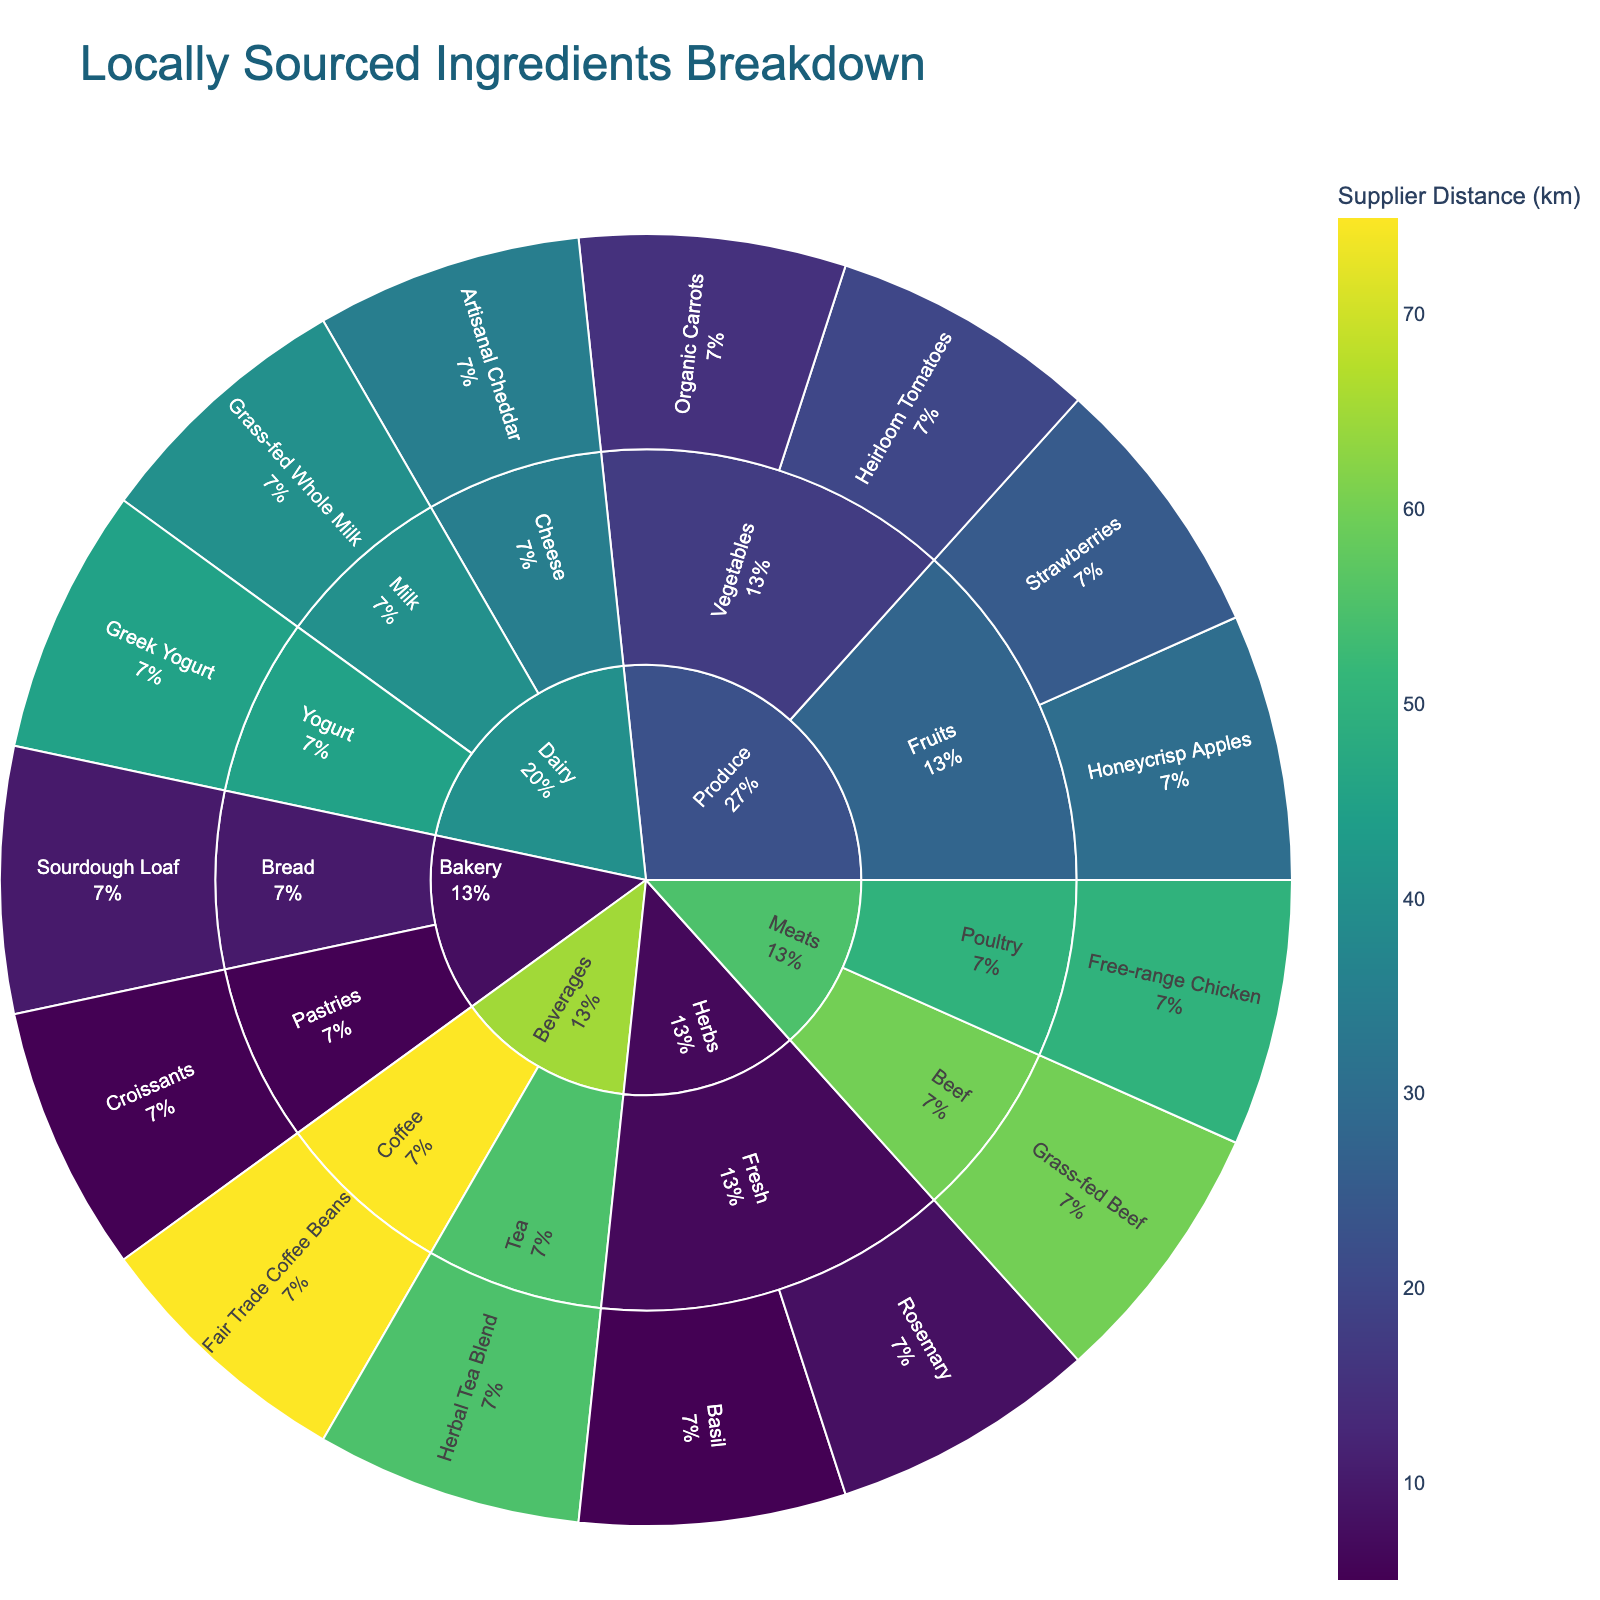What is the main title of the sunburst plot? The main title is displayed at the top of the plot, and it describes the figure's overall subject.
Answer: Locally Sourced Ingredients Breakdown How many subcategories are there within the 'Produce' category? The sunburst plot consists of hierarchical sections, and we count the segments directly under 'Produce' to identify the number of subcategories.
Answer: 2 Which food item has the shortest supplier distance? By examining the color scale for 'supplier distance' and selecting the most intense color corresponding to the shortest distance, we identify the item.
Answer: Croissants What is the seasonality of 'Basil'? Hover over the segment that represents 'Basil' to see the additional information displayed about seasonality.
Answer: Summer Which category has the highest variety of food items? By counting how many items each category has on the plot, we determine the one with the most segments.
Answer: Produce How many items are sourced year-round? Count all outer segments with 'Year-round' hover information to total the number of such items.
Answer: 10 What is the average supplier distance for items in the 'Dairy' category? Calculate by adding the supplier distances for each item under 'Dairy' and dividing by the number of items. 
Grass-fed Whole Milk: 40 km, Artisanal Cheddar: 35 km, Greek Yogurt: 45 km. 
Sum: 40 + 35 + 45 = 120. 
Average: 120 / 3 = 40.
Answer: 40 km Which category contains the item with the longest supplier distance? Identify the segment with the most muted color scale indicating the longest distance, and trace it back to its main category.
Answer: Beverages During which season is 'Heirloom Tomatoes' sourced? Hover over and view the additional seasonality information displayed for 'Heirloom Tomatoes'.
Answer: Summer Compare the number of items in the 'Herbs' category to the 'Beverages' category. Which has more, and by how many? Count the items in both 'Herbs' and 'Beverages' categories and subtract to see the difference.
Herbs: 2 items
Beverages: 2 items 
Difference: 2 - 2 = 0
Answer: They have the same number of items 